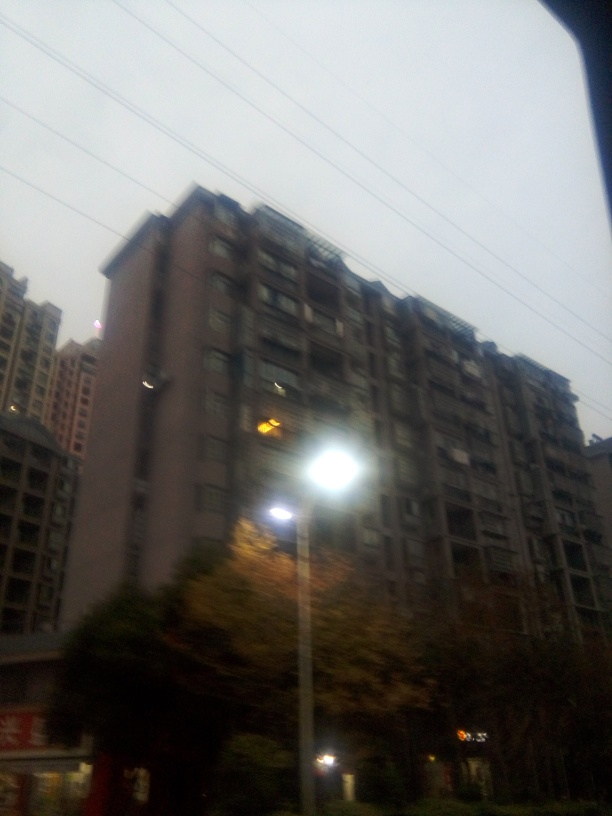What time of day does this image appear to represent, and how can you tell? Based on the low light conditions and the one lit window, it appears to be either dawn or dusk. The exact time of day is difficult to identify due to the image's overall low visibility, but the presence of artificial lighting and limited natural light suggests that it's not midday. What could indicate this image was taken from inside a vehicle? The reflection and the angle of the image suggest that it was taken through a window, likely a car window based on the elevated viewpoint and the curvature at the bottom, resembling a vehicle's interior. 